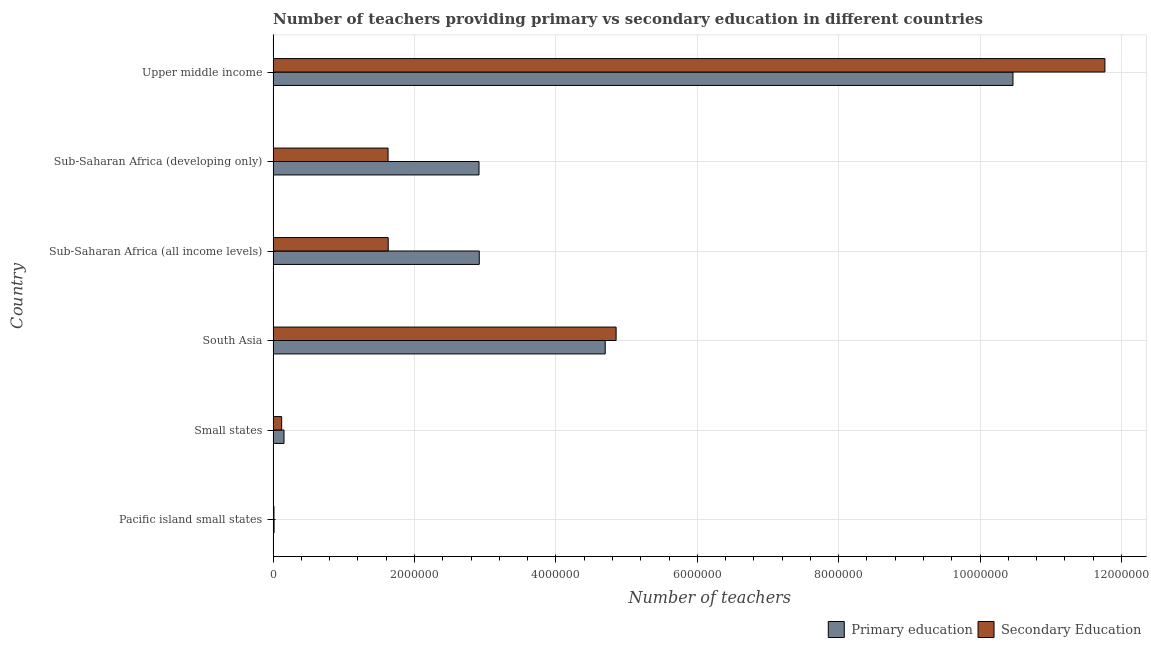How many groups of bars are there?
Your answer should be compact. 6. How many bars are there on the 4th tick from the top?
Make the answer very short. 2. How many bars are there on the 5th tick from the bottom?
Keep it short and to the point. 2. What is the label of the 2nd group of bars from the top?
Make the answer very short. Sub-Saharan Africa (developing only). What is the number of primary teachers in Sub-Saharan Africa (developing only)?
Offer a very short reply. 2.91e+06. Across all countries, what is the maximum number of primary teachers?
Your answer should be very brief. 1.05e+07. Across all countries, what is the minimum number of secondary teachers?
Your answer should be compact. 1.20e+04. In which country was the number of primary teachers maximum?
Offer a very short reply. Upper middle income. In which country was the number of primary teachers minimum?
Your response must be concise. Pacific island small states. What is the total number of secondary teachers in the graph?
Your answer should be very brief. 2.00e+07. What is the difference between the number of primary teachers in Pacific island small states and that in Sub-Saharan Africa (developing only)?
Keep it short and to the point. -2.90e+06. What is the difference between the number of secondary teachers in Sub-Saharan Africa (all income levels) and the number of primary teachers in Sub-Saharan Africa (developing only)?
Your answer should be very brief. -1.28e+06. What is the average number of secondary teachers per country?
Keep it short and to the point. 3.33e+06. What is the difference between the number of secondary teachers and number of primary teachers in Upper middle income?
Provide a short and direct response. 1.30e+06. In how many countries, is the number of secondary teachers greater than 6400000 ?
Offer a very short reply. 1. What is the ratio of the number of secondary teachers in South Asia to that in Sub-Saharan Africa (developing only)?
Offer a terse response. 2.98. Is the difference between the number of primary teachers in South Asia and Sub-Saharan Africa (developing only) greater than the difference between the number of secondary teachers in South Asia and Sub-Saharan Africa (developing only)?
Offer a terse response. No. What is the difference between the highest and the second highest number of primary teachers?
Make the answer very short. 5.77e+06. What is the difference between the highest and the lowest number of secondary teachers?
Make the answer very short. 1.18e+07. In how many countries, is the number of secondary teachers greater than the average number of secondary teachers taken over all countries?
Make the answer very short. 2. Is the sum of the number of secondary teachers in Small states and South Asia greater than the maximum number of primary teachers across all countries?
Your response must be concise. No. What does the 1st bar from the top in Pacific island small states represents?
Keep it short and to the point. Secondary Education. What does the 2nd bar from the bottom in Small states represents?
Provide a succinct answer. Secondary Education. How many bars are there?
Offer a very short reply. 12. How many countries are there in the graph?
Offer a terse response. 6. Are the values on the major ticks of X-axis written in scientific E-notation?
Provide a short and direct response. No. Where does the legend appear in the graph?
Your response must be concise. Bottom right. How many legend labels are there?
Make the answer very short. 2. What is the title of the graph?
Your answer should be very brief. Number of teachers providing primary vs secondary education in different countries. Does "Private consumption" appear as one of the legend labels in the graph?
Offer a very short reply. No. What is the label or title of the X-axis?
Keep it short and to the point. Number of teachers. What is the label or title of the Y-axis?
Offer a very short reply. Country. What is the Number of teachers of Primary education in Pacific island small states?
Give a very brief answer. 1.35e+04. What is the Number of teachers in Secondary Education in Pacific island small states?
Offer a very short reply. 1.20e+04. What is the Number of teachers in Primary education in Small states?
Provide a short and direct response. 1.54e+05. What is the Number of teachers in Secondary Education in Small states?
Keep it short and to the point. 1.21e+05. What is the Number of teachers of Primary education in South Asia?
Make the answer very short. 4.70e+06. What is the Number of teachers in Secondary Education in South Asia?
Provide a succinct answer. 4.85e+06. What is the Number of teachers in Primary education in Sub-Saharan Africa (all income levels)?
Ensure brevity in your answer.  2.92e+06. What is the Number of teachers in Secondary Education in Sub-Saharan Africa (all income levels)?
Offer a terse response. 1.63e+06. What is the Number of teachers in Primary education in Sub-Saharan Africa (developing only)?
Make the answer very short. 2.91e+06. What is the Number of teachers of Secondary Education in Sub-Saharan Africa (developing only)?
Ensure brevity in your answer.  1.63e+06. What is the Number of teachers of Primary education in Upper middle income?
Your answer should be very brief. 1.05e+07. What is the Number of teachers in Secondary Education in Upper middle income?
Provide a short and direct response. 1.18e+07. Across all countries, what is the maximum Number of teachers in Primary education?
Ensure brevity in your answer.  1.05e+07. Across all countries, what is the maximum Number of teachers in Secondary Education?
Your response must be concise. 1.18e+07. Across all countries, what is the minimum Number of teachers of Primary education?
Your response must be concise. 1.35e+04. Across all countries, what is the minimum Number of teachers of Secondary Education?
Give a very brief answer. 1.20e+04. What is the total Number of teachers of Primary education in the graph?
Your answer should be compact. 2.12e+07. What is the total Number of teachers in Secondary Education in the graph?
Provide a succinct answer. 2.00e+07. What is the difference between the Number of teachers of Primary education in Pacific island small states and that in Small states?
Your response must be concise. -1.40e+05. What is the difference between the Number of teachers of Secondary Education in Pacific island small states and that in Small states?
Your response must be concise. -1.09e+05. What is the difference between the Number of teachers in Primary education in Pacific island small states and that in South Asia?
Keep it short and to the point. -4.68e+06. What is the difference between the Number of teachers of Secondary Education in Pacific island small states and that in South Asia?
Offer a very short reply. -4.84e+06. What is the difference between the Number of teachers in Primary education in Pacific island small states and that in Sub-Saharan Africa (all income levels)?
Provide a short and direct response. -2.90e+06. What is the difference between the Number of teachers of Secondary Education in Pacific island small states and that in Sub-Saharan Africa (all income levels)?
Give a very brief answer. -1.62e+06. What is the difference between the Number of teachers of Primary education in Pacific island small states and that in Sub-Saharan Africa (developing only)?
Provide a succinct answer. -2.90e+06. What is the difference between the Number of teachers in Secondary Education in Pacific island small states and that in Sub-Saharan Africa (developing only)?
Give a very brief answer. -1.61e+06. What is the difference between the Number of teachers of Primary education in Pacific island small states and that in Upper middle income?
Provide a short and direct response. -1.05e+07. What is the difference between the Number of teachers in Secondary Education in Pacific island small states and that in Upper middle income?
Provide a succinct answer. -1.18e+07. What is the difference between the Number of teachers of Primary education in Small states and that in South Asia?
Your answer should be compact. -4.54e+06. What is the difference between the Number of teachers of Secondary Education in Small states and that in South Asia?
Make the answer very short. -4.73e+06. What is the difference between the Number of teachers of Primary education in Small states and that in Sub-Saharan Africa (all income levels)?
Ensure brevity in your answer.  -2.76e+06. What is the difference between the Number of teachers of Secondary Education in Small states and that in Sub-Saharan Africa (all income levels)?
Your response must be concise. -1.51e+06. What is the difference between the Number of teachers in Primary education in Small states and that in Sub-Saharan Africa (developing only)?
Ensure brevity in your answer.  -2.76e+06. What is the difference between the Number of teachers in Secondary Education in Small states and that in Sub-Saharan Africa (developing only)?
Your answer should be compact. -1.51e+06. What is the difference between the Number of teachers in Primary education in Small states and that in Upper middle income?
Provide a succinct answer. -1.03e+07. What is the difference between the Number of teachers in Secondary Education in Small states and that in Upper middle income?
Give a very brief answer. -1.16e+07. What is the difference between the Number of teachers of Primary education in South Asia and that in Sub-Saharan Africa (all income levels)?
Offer a very short reply. 1.78e+06. What is the difference between the Number of teachers of Secondary Education in South Asia and that in Sub-Saharan Africa (all income levels)?
Provide a succinct answer. 3.22e+06. What is the difference between the Number of teachers in Primary education in South Asia and that in Sub-Saharan Africa (developing only)?
Make the answer very short. 1.79e+06. What is the difference between the Number of teachers in Secondary Education in South Asia and that in Sub-Saharan Africa (developing only)?
Keep it short and to the point. 3.23e+06. What is the difference between the Number of teachers of Primary education in South Asia and that in Upper middle income?
Ensure brevity in your answer.  -5.77e+06. What is the difference between the Number of teachers of Secondary Education in South Asia and that in Upper middle income?
Your answer should be very brief. -6.91e+06. What is the difference between the Number of teachers in Primary education in Sub-Saharan Africa (all income levels) and that in Sub-Saharan Africa (developing only)?
Your answer should be very brief. 3570. What is the difference between the Number of teachers in Secondary Education in Sub-Saharan Africa (all income levels) and that in Sub-Saharan Africa (developing only)?
Your answer should be very brief. 1772.12. What is the difference between the Number of teachers of Primary education in Sub-Saharan Africa (all income levels) and that in Upper middle income?
Make the answer very short. -7.55e+06. What is the difference between the Number of teachers in Secondary Education in Sub-Saharan Africa (all income levels) and that in Upper middle income?
Give a very brief answer. -1.01e+07. What is the difference between the Number of teachers of Primary education in Sub-Saharan Africa (developing only) and that in Upper middle income?
Your response must be concise. -7.55e+06. What is the difference between the Number of teachers in Secondary Education in Sub-Saharan Africa (developing only) and that in Upper middle income?
Offer a terse response. -1.01e+07. What is the difference between the Number of teachers of Primary education in Pacific island small states and the Number of teachers of Secondary Education in Small states?
Keep it short and to the point. -1.07e+05. What is the difference between the Number of teachers in Primary education in Pacific island small states and the Number of teachers in Secondary Education in South Asia?
Make the answer very short. -4.84e+06. What is the difference between the Number of teachers of Primary education in Pacific island small states and the Number of teachers of Secondary Education in Sub-Saharan Africa (all income levels)?
Your answer should be compact. -1.61e+06. What is the difference between the Number of teachers in Primary education in Pacific island small states and the Number of teachers in Secondary Education in Sub-Saharan Africa (developing only)?
Offer a very short reply. -1.61e+06. What is the difference between the Number of teachers of Primary education in Pacific island small states and the Number of teachers of Secondary Education in Upper middle income?
Give a very brief answer. -1.18e+07. What is the difference between the Number of teachers in Primary education in Small states and the Number of teachers in Secondary Education in South Asia?
Offer a very short reply. -4.70e+06. What is the difference between the Number of teachers of Primary education in Small states and the Number of teachers of Secondary Education in Sub-Saharan Africa (all income levels)?
Your response must be concise. -1.47e+06. What is the difference between the Number of teachers in Primary education in Small states and the Number of teachers in Secondary Education in Sub-Saharan Africa (developing only)?
Make the answer very short. -1.47e+06. What is the difference between the Number of teachers in Primary education in Small states and the Number of teachers in Secondary Education in Upper middle income?
Provide a short and direct response. -1.16e+07. What is the difference between the Number of teachers of Primary education in South Asia and the Number of teachers of Secondary Education in Sub-Saharan Africa (all income levels)?
Provide a short and direct response. 3.07e+06. What is the difference between the Number of teachers of Primary education in South Asia and the Number of teachers of Secondary Education in Sub-Saharan Africa (developing only)?
Offer a very short reply. 3.07e+06. What is the difference between the Number of teachers in Primary education in South Asia and the Number of teachers in Secondary Education in Upper middle income?
Ensure brevity in your answer.  -7.07e+06. What is the difference between the Number of teachers of Primary education in Sub-Saharan Africa (all income levels) and the Number of teachers of Secondary Education in Sub-Saharan Africa (developing only)?
Make the answer very short. 1.29e+06. What is the difference between the Number of teachers of Primary education in Sub-Saharan Africa (all income levels) and the Number of teachers of Secondary Education in Upper middle income?
Give a very brief answer. -8.85e+06. What is the difference between the Number of teachers in Primary education in Sub-Saharan Africa (developing only) and the Number of teachers in Secondary Education in Upper middle income?
Offer a very short reply. -8.85e+06. What is the average Number of teachers of Primary education per country?
Offer a terse response. 3.53e+06. What is the average Number of teachers of Secondary Education per country?
Offer a terse response. 3.33e+06. What is the difference between the Number of teachers in Primary education and Number of teachers in Secondary Education in Pacific island small states?
Your response must be concise. 1514.46. What is the difference between the Number of teachers in Primary education and Number of teachers in Secondary Education in Small states?
Your answer should be compact. 3.30e+04. What is the difference between the Number of teachers of Primary education and Number of teachers of Secondary Education in South Asia?
Provide a short and direct response. -1.54e+05. What is the difference between the Number of teachers in Primary education and Number of teachers in Secondary Education in Sub-Saharan Africa (all income levels)?
Your answer should be compact. 1.29e+06. What is the difference between the Number of teachers of Primary education and Number of teachers of Secondary Education in Sub-Saharan Africa (developing only)?
Offer a very short reply. 1.29e+06. What is the difference between the Number of teachers of Primary education and Number of teachers of Secondary Education in Upper middle income?
Offer a terse response. -1.30e+06. What is the ratio of the Number of teachers of Primary education in Pacific island small states to that in Small states?
Provide a short and direct response. 0.09. What is the ratio of the Number of teachers of Secondary Education in Pacific island small states to that in Small states?
Give a very brief answer. 0.1. What is the ratio of the Number of teachers of Primary education in Pacific island small states to that in South Asia?
Offer a terse response. 0. What is the ratio of the Number of teachers in Secondary Education in Pacific island small states to that in South Asia?
Ensure brevity in your answer.  0. What is the ratio of the Number of teachers of Primary education in Pacific island small states to that in Sub-Saharan Africa (all income levels)?
Provide a short and direct response. 0. What is the ratio of the Number of teachers in Secondary Education in Pacific island small states to that in Sub-Saharan Africa (all income levels)?
Give a very brief answer. 0.01. What is the ratio of the Number of teachers in Primary education in Pacific island small states to that in Sub-Saharan Africa (developing only)?
Keep it short and to the point. 0. What is the ratio of the Number of teachers of Secondary Education in Pacific island small states to that in Sub-Saharan Africa (developing only)?
Offer a very short reply. 0.01. What is the ratio of the Number of teachers in Primary education in Pacific island small states to that in Upper middle income?
Give a very brief answer. 0. What is the ratio of the Number of teachers in Primary education in Small states to that in South Asia?
Provide a short and direct response. 0.03. What is the ratio of the Number of teachers of Secondary Education in Small states to that in South Asia?
Give a very brief answer. 0.02. What is the ratio of the Number of teachers in Primary education in Small states to that in Sub-Saharan Africa (all income levels)?
Your answer should be compact. 0.05. What is the ratio of the Number of teachers of Secondary Education in Small states to that in Sub-Saharan Africa (all income levels)?
Keep it short and to the point. 0.07. What is the ratio of the Number of teachers of Primary education in Small states to that in Sub-Saharan Africa (developing only)?
Offer a very short reply. 0.05. What is the ratio of the Number of teachers in Secondary Education in Small states to that in Sub-Saharan Africa (developing only)?
Your answer should be very brief. 0.07. What is the ratio of the Number of teachers of Primary education in Small states to that in Upper middle income?
Your answer should be very brief. 0.01. What is the ratio of the Number of teachers of Secondary Education in Small states to that in Upper middle income?
Give a very brief answer. 0.01. What is the ratio of the Number of teachers in Primary education in South Asia to that in Sub-Saharan Africa (all income levels)?
Your response must be concise. 1.61. What is the ratio of the Number of teachers of Secondary Education in South Asia to that in Sub-Saharan Africa (all income levels)?
Ensure brevity in your answer.  2.98. What is the ratio of the Number of teachers of Primary education in South Asia to that in Sub-Saharan Africa (developing only)?
Offer a very short reply. 1.61. What is the ratio of the Number of teachers in Secondary Education in South Asia to that in Sub-Saharan Africa (developing only)?
Ensure brevity in your answer.  2.98. What is the ratio of the Number of teachers of Primary education in South Asia to that in Upper middle income?
Your answer should be very brief. 0.45. What is the ratio of the Number of teachers of Secondary Education in South Asia to that in Upper middle income?
Ensure brevity in your answer.  0.41. What is the ratio of the Number of teachers in Primary education in Sub-Saharan Africa (all income levels) to that in Sub-Saharan Africa (developing only)?
Provide a short and direct response. 1. What is the ratio of the Number of teachers of Secondary Education in Sub-Saharan Africa (all income levels) to that in Sub-Saharan Africa (developing only)?
Offer a terse response. 1. What is the ratio of the Number of teachers in Primary education in Sub-Saharan Africa (all income levels) to that in Upper middle income?
Make the answer very short. 0.28. What is the ratio of the Number of teachers in Secondary Education in Sub-Saharan Africa (all income levels) to that in Upper middle income?
Give a very brief answer. 0.14. What is the ratio of the Number of teachers of Primary education in Sub-Saharan Africa (developing only) to that in Upper middle income?
Offer a very short reply. 0.28. What is the ratio of the Number of teachers in Secondary Education in Sub-Saharan Africa (developing only) to that in Upper middle income?
Your response must be concise. 0.14. What is the difference between the highest and the second highest Number of teachers in Primary education?
Keep it short and to the point. 5.77e+06. What is the difference between the highest and the second highest Number of teachers of Secondary Education?
Offer a terse response. 6.91e+06. What is the difference between the highest and the lowest Number of teachers of Primary education?
Provide a short and direct response. 1.05e+07. What is the difference between the highest and the lowest Number of teachers of Secondary Education?
Ensure brevity in your answer.  1.18e+07. 